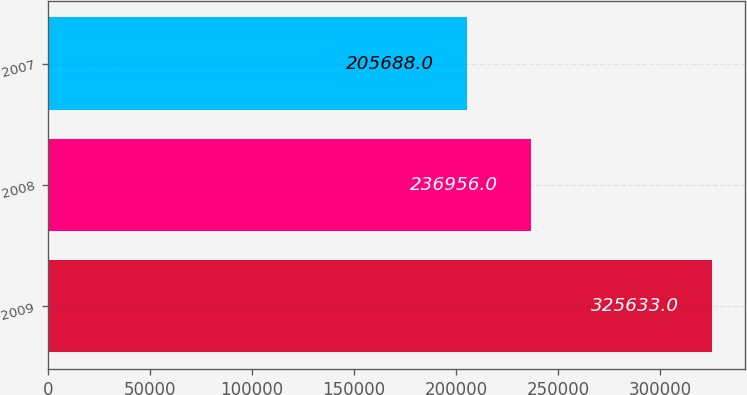<chart> <loc_0><loc_0><loc_500><loc_500><bar_chart><fcel>2009<fcel>2008<fcel>2007<nl><fcel>325633<fcel>236956<fcel>205688<nl></chart> 